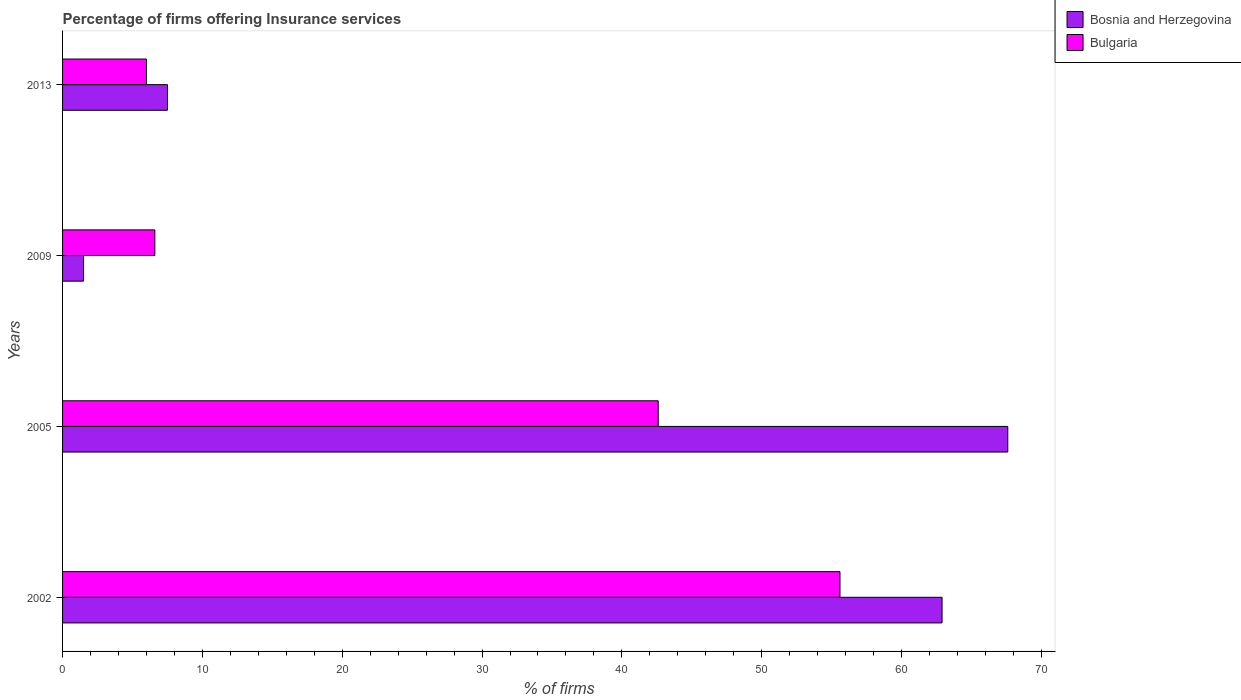How many different coloured bars are there?
Give a very brief answer. 2. Are the number of bars per tick equal to the number of legend labels?
Offer a terse response. Yes. Are the number of bars on each tick of the Y-axis equal?
Offer a very short reply. Yes. What is the label of the 4th group of bars from the top?
Your response must be concise. 2002. In how many cases, is the number of bars for a given year not equal to the number of legend labels?
Your answer should be compact. 0. What is the percentage of firms offering insurance services in Bulgaria in 2002?
Your answer should be very brief. 55.6. Across all years, what is the maximum percentage of firms offering insurance services in Bulgaria?
Offer a very short reply. 55.6. In which year was the percentage of firms offering insurance services in Bosnia and Herzegovina minimum?
Offer a terse response. 2009. What is the total percentage of firms offering insurance services in Bulgaria in the graph?
Your answer should be very brief. 110.8. What is the difference between the percentage of firms offering insurance services in Bulgaria in 2005 and that in 2009?
Keep it short and to the point. 36. What is the difference between the percentage of firms offering insurance services in Bulgaria in 2013 and the percentage of firms offering insurance services in Bosnia and Herzegovina in 2002?
Your response must be concise. -56.9. What is the average percentage of firms offering insurance services in Bosnia and Herzegovina per year?
Your answer should be compact. 34.88. In the year 2005, what is the difference between the percentage of firms offering insurance services in Bosnia and Herzegovina and percentage of firms offering insurance services in Bulgaria?
Provide a short and direct response. 25. What is the ratio of the percentage of firms offering insurance services in Bosnia and Herzegovina in 2005 to that in 2013?
Make the answer very short. 9.01. Is the difference between the percentage of firms offering insurance services in Bosnia and Herzegovina in 2005 and 2013 greater than the difference between the percentage of firms offering insurance services in Bulgaria in 2005 and 2013?
Provide a succinct answer. Yes. What is the difference between the highest and the second highest percentage of firms offering insurance services in Bulgaria?
Provide a succinct answer. 13. What is the difference between the highest and the lowest percentage of firms offering insurance services in Bulgaria?
Provide a succinct answer. 49.6. In how many years, is the percentage of firms offering insurance services in Bosnia and Herzegovina greater than the average percentage of firms offering insurance services in Bosnia and Herzegovina taken over all years?
Keep it short and to the point. 2. Is the sum of the percentage of firms offering insurance services in Bulgaria in 2002 and 2005 greater than the maximum percentage of firms offering insurance services in Bosnia and Herzegovina across all years?
Your answer should be compact. Yes. Where does the legend appear in the graph?
Ensure brevity in your answer.  Top right. How are the legend labels stacked?
Your response must be concise. Vertical. What is the title of the graph?
Keep it short and to the point. Percentage of firms offering Insurance services. Does "Kenya" appear as one of the legend labels in the graph?
Give a very brief answer. No. What is the label or title of the X-axis?
Make the answer very short. % of firms. What is the label or title of the Y-axis?
Keep it short and to the point. Years. What is the % of firms of Bosnia and Herzegovina in 2002?
Your answer should be very brief. 62.9. What is the % of firms of Bulgaria in 2002?
Provide a short and direct response. 55.6. What is the % of firms in Bosnia and Herzegovina in 2005?
Your response must be concise. 67.6. What is the % of firms of Bulgaria in 2005?
Your answer should be very brief. 42.6. What is the % of firms in Bulgaria in 2009?
Your answer should be very brief. 6.6. Across all years, what is the maximum % of firms in Bosnia and Herzegovina?
Keep it short and to the point. 67.6. Across all years, what is the maximum % of firms of Bulgaria?
Your response must be concise. 55.6. Across all years, what is the minimum % of firms of Bulgaria?
Offer a very short reply. 6. What is the total % of firms in Bosnia and Herzegovina in the graph?
Offer a very short reply. 139.5. What is the total % of firms in Bulgaria in the graph?
Your answer should be compact. 110.8. What is the difference between the % of firms of Bosnia and Herzegovina in 2002 and that in 2005?
Your answer should be very brief. -4.7. What is the difference between the % of firms of Bosnia and Herzegovina in 2002 and that in 2009?
Ensure brevity in your answer.  61.4. What is the difference between the % of firms in Bosnia and Herzegovina in 2002 and that in 2013?
Provide a succinct answer. 55.4. What is the difference between the % of firms in Bulgaria in 2002 and that in 2013?
Your response must be concise. 49.6. What is the difference between the % of firms in Bosnia and Herzegovina in 2005 and that in 2009?
Your answer should be compact. 66.1. What is the difference between the % of firms of Bosnia and Herzegovina in 2005 and that in 2013?
Make the answer very short. 60.1. What is the difference between the % of firms in Bulgaria in 2005 and that in 2013?
Provide a short and direct response. 36.6. What is the difference between the % of firms of Bosnia and Herzegovina in 2009 and that in 2013?
Your answer should be compact. -6. What is the difference between the % of firms in Bosnia and Herzegovina in 2002 and the % of firms in Bulgaria in 2005?
Your answer should be compact. 20.3. What is the difference between the % of firms of Bosnia and Herzegovina in 2002 and the % of firms of Bulgaria in 2009?
Provide a succinct answer. 56.3. What is the difference between the % of firms of Bosnia and Herzegovina in 2002 and the % of firms of Bulgaria in 2013?
Provide a succinct answer. 56.9. What is the difference between the % of firms of Bosnia and Herzegovina in 2005 and the % of firms of Bulgaria in 2013?
Provide a short and direct response. 61.6. What is the difference between the % of firms in Bosnia and Herzegovina in 2009 and the % of firms in Bulgaria in 2013?
Keep it short and to the point. -4.5. What is the average % of firms of Bosnia and Herzegovina per year?
Give a very brief answer. 34.88. What is the average % of firms of Bulgaria per year?
Your answer should be compact. 27.7. In the year 2002, what is the difference between the % of firms in Bosnia and Herzegovina and % of firms in Bulgaria?
Provide a short and direct response. 7.3. In the year 2009, what is the difference between the % of firms in Bosnia and Herzegovina and % of firms in Bulgaria?
Make the answer very short. -5.1. What is the ratio of the % of firms of Bosnia and Herzegovina in 2002 to that in 2005?
Make the answer very short. 0.93. What is the ratio of the % of firms in Bulgaria in 2002 to that in 2005?
Provide a succinct answer. 1.31. What is the ratio of the % of firms of Bosnia and Herzegovina in 2002 to that in 2009?
Your answer should be very brief. 41.93. What is the ratio of the % of firms in Bulgaria in 2002 to that in 2009?
Offer a very short reply. 8.42. What is the ratio of the % of firms of Bosnia and Herzegovina in 2002 to that in 2013?
Provide a succinct answer. 8.39. What is the ratio of the % of firms in Bulgaria in 2002 to that in 2013?
Your answer should be very brief. 9.27. What is the ratio of the % of firms in Bosnia and Herzegovina in 2005 to that in 2009?
Make the answer very short. 45.07. What is the ratio of the % of firms of Bulgaria in 2005 to that in 2009?
Make the answer very short. 6.45. What is the ratio of the % of firms in Bosnia and Herzegovina in 2005 to that in 2013?
Make the answer very short. 9.01. What is the ratio of the % of firms of Bosnia and Herzegovina in 2009 to that in 2013?
Offer a very short reply. 0.2. What is the ratio of the % of firms of Bulgaria in 2009 to that in 2013?
Your response must be concise. 1.1. What is the difference between the highest and the second highest % of firms of Bosnia and Herzegovina?
Make the answer very short. 4.7. What is the difference between the highest and the lowest % of firms in Bosnia and Herzegovina?
Offer a very short reply. 66.1. What is the difference between the highest and the lowest % of firms in Bulgaria?
Give a very brief answer. 49.6. 